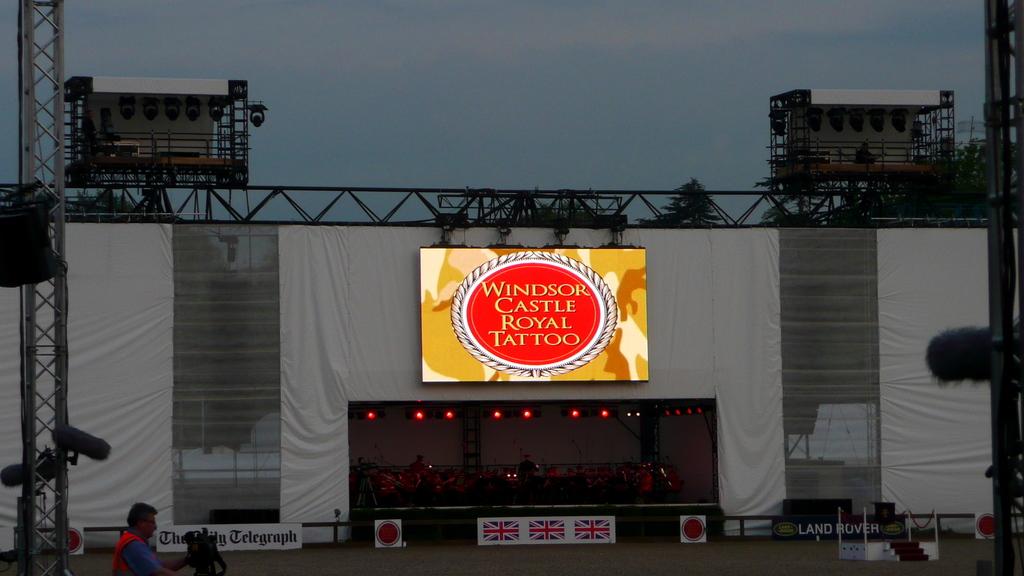Which castle does the sign refer to?
Your answer should be very brief. Windsor. What does this sign say?
Your answer should be compact. Windsor castle royal tattoo. 